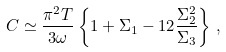Convert formula to latex. <formula><loc_0><loc_0><loc_500><loc_500>C \simeq \frac { \pi ^ { 2 } T } { 3 \omega } \left \{ 1 + \Sigma _ { 1 } - 1 2 \frac { \Sigma _ { 2 } ^ { 2 } } { \Sigma _ { 3 } } \right \} \, ,</formula> 